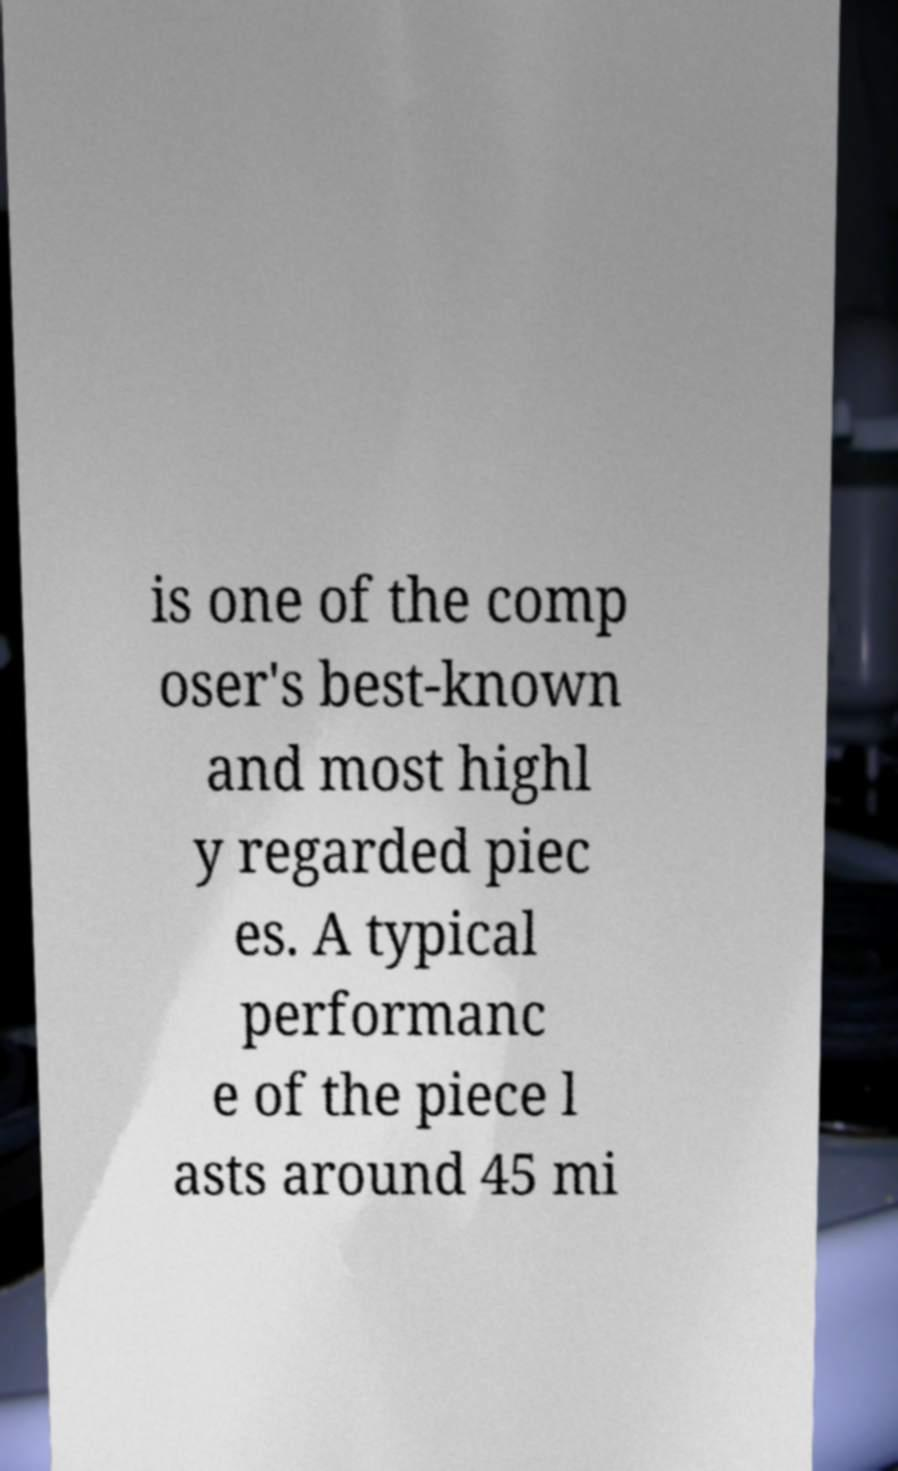Could you extract and type out the text from this image? is one of the comp oser's best-known and most highl y regarded piec es. A typical performanc e of the piece l asts around 45 mi 